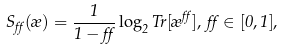<formula> <loc_0><loc_0><loc_500><loc_500>S _ { \alpha } ( \rho ) = \frac { 1 } { 1 - \alpha } \log _ { 2 } T r [ \rho ^ { \alpha } ] , \, \alpha \in [ 0 , 1 ] ,</formula> 